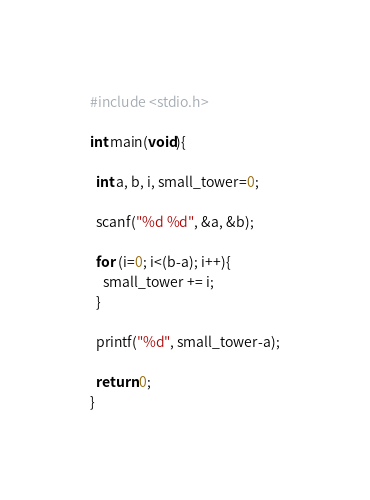Convert code to text. <code><loc_0><loc_0><loc_500><loc_500><_C_>#include <stdio.h>

int main(void){
  
  int a, b, i, small_tower=0;

  scanf("%d %d", &a, &b);

  for (i=0; i<(b-a); i++){
    small_tower += i;
  }

  printf("%d", small_tower-a);

  return 0;
}</code> 